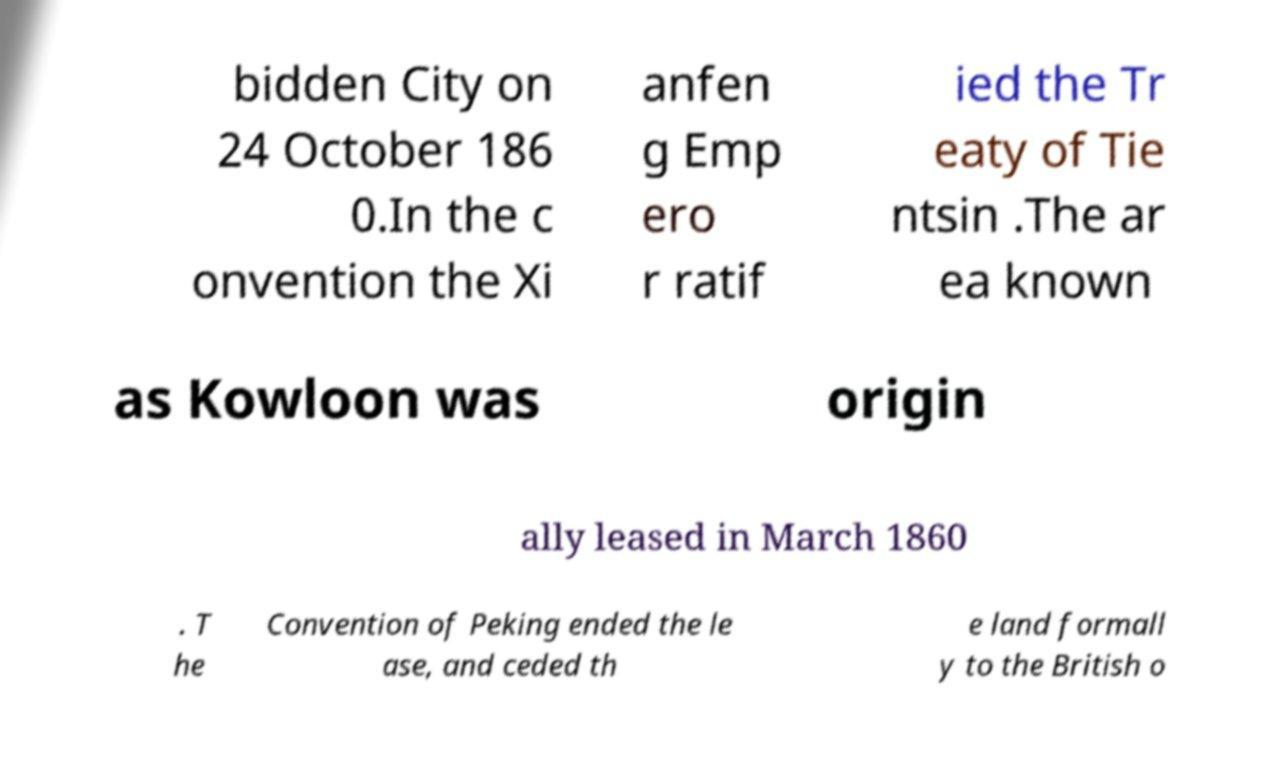Could you assist in decoding the text presented in this image and type it out clearly? bidden City on 24 October 186 0.In the c onvention the Xi anfen g Emp ero r ratif ied the Tr eaty of Tie ntsin .The ar ea known as Kowloon was origin ally leased in March 1860 . T he Convention of Peking ended the le ase, and ceded th e land formall y to the British o 